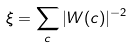Convert formula to latex. <formula><loc_0><loc_0><loc_500><loc_500>\xi = \sum _ { c } | W ( c ) | ^ { - 2 }</formula> 